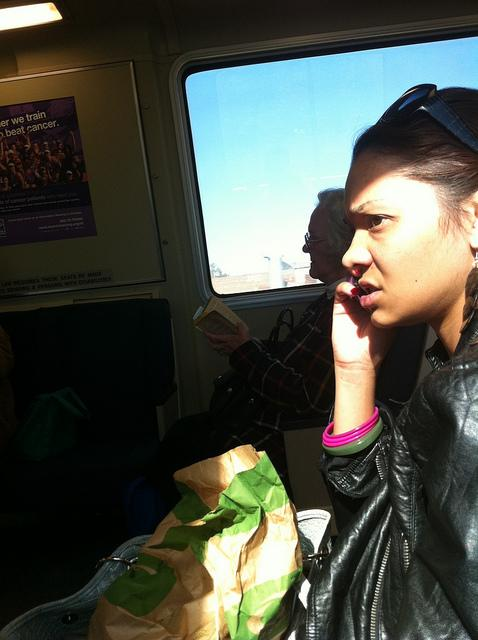What is the brown and green bag made from? Please explain your reasoning. paper. The brown and green bag is a crinkled paper looking material. 